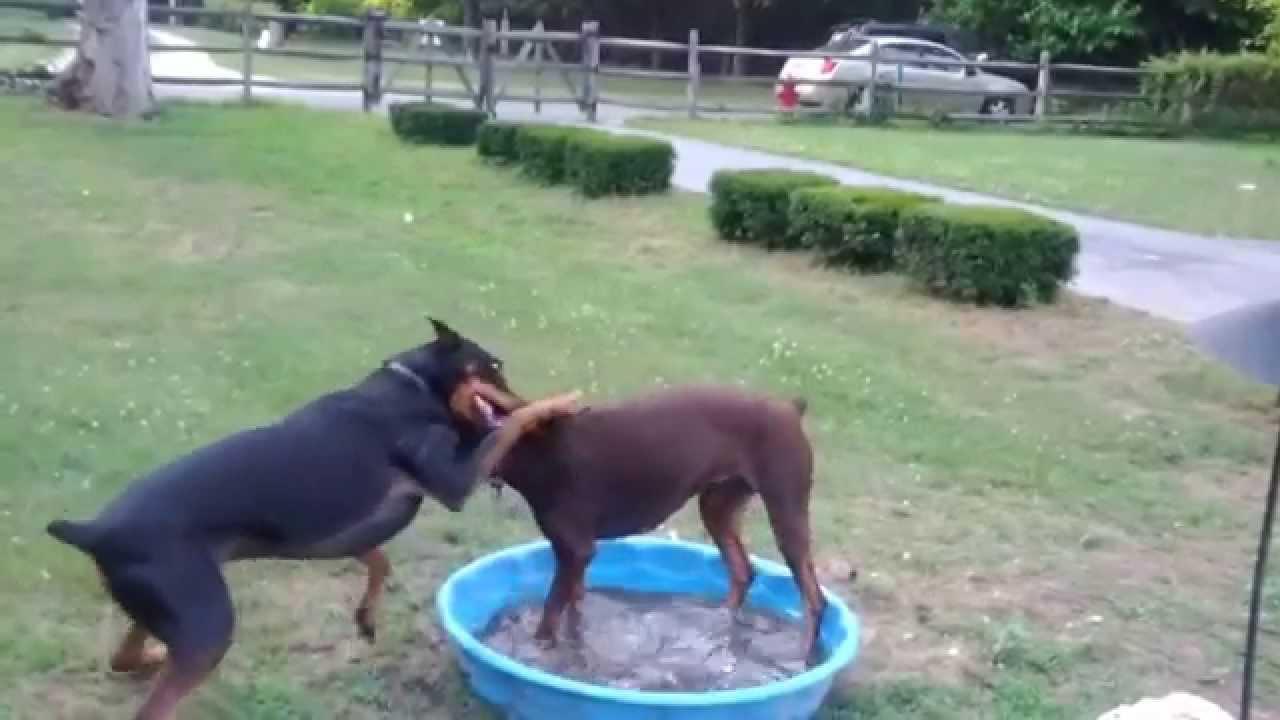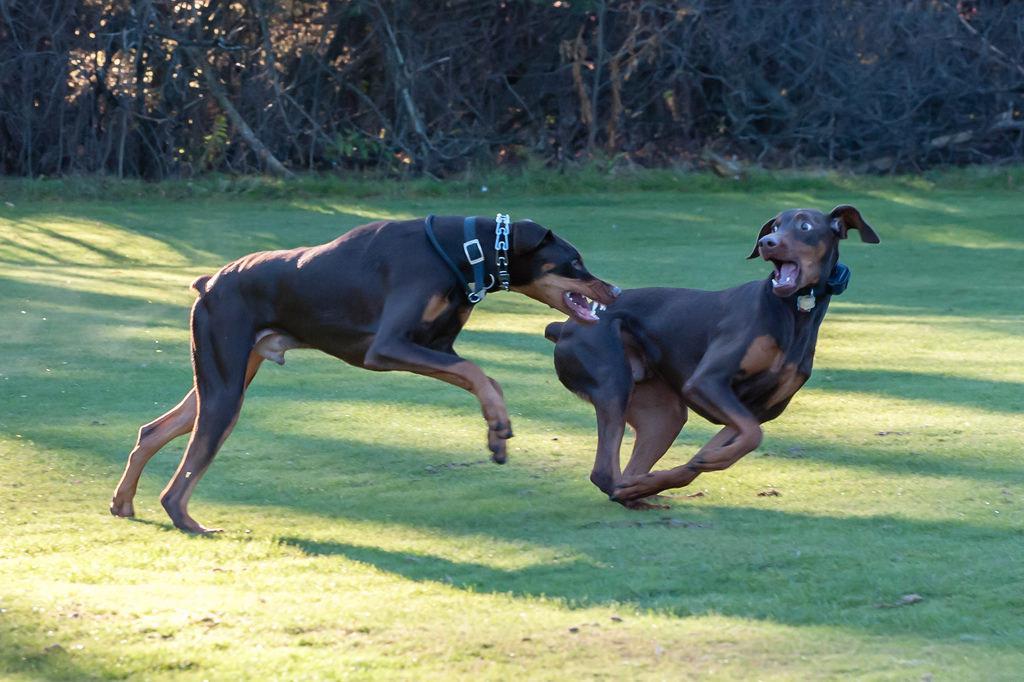The first image is the image on the left, the second image is the image on the right. Examine the images to the left and right. Is the description "The right image contains exactly two dogs." accurate? Answer yes or no. Yes. The first image is the image on the left, the second image is the image on the right. Assess this claim about the two images: "Each image shows two dogs of similar size interacting in close proximity.". Correct or not? Answer yes or no. Yes. 